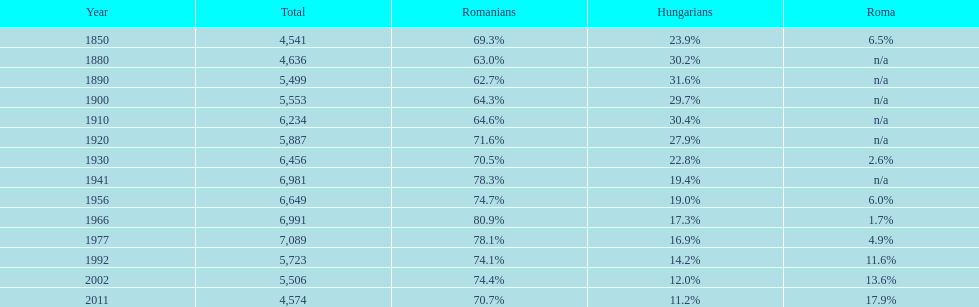4%? 1941. 